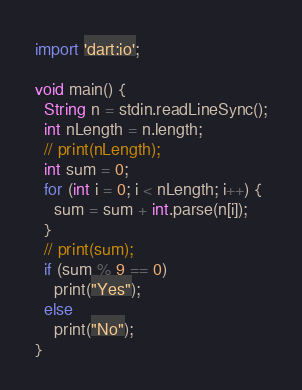<code> <loc_0><loc_0><loc_500><loc_500><_Dart_>import 'dart:io';

void main() {
  String n = stdin.readLineSync();
  int nLength = n.length;
  // print(nLength);
  int sum = 0;
  for (int i = 0; i < nLength; i++) {
    sum = sum + int.parse(n[i]);
  }
  // print(sum);
  if (sum % 9 == 0)
    print("Yes");
  else
    print("No");
}
</code> 